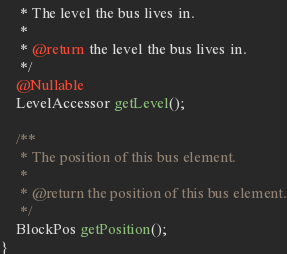Convert code to text. <code><loc_0><loc_0><loc_500><loc_500><_Java_>     * The level the bus lives in.
     *
     * @return the level the bus lives in.
     */
    @Nullable
    LevelAccessor getLevel();

    /**
     * The position of this bus element.
     *
     * @return the position of this bus element.
     */
    BlockPos getPosition();
}
</code> 